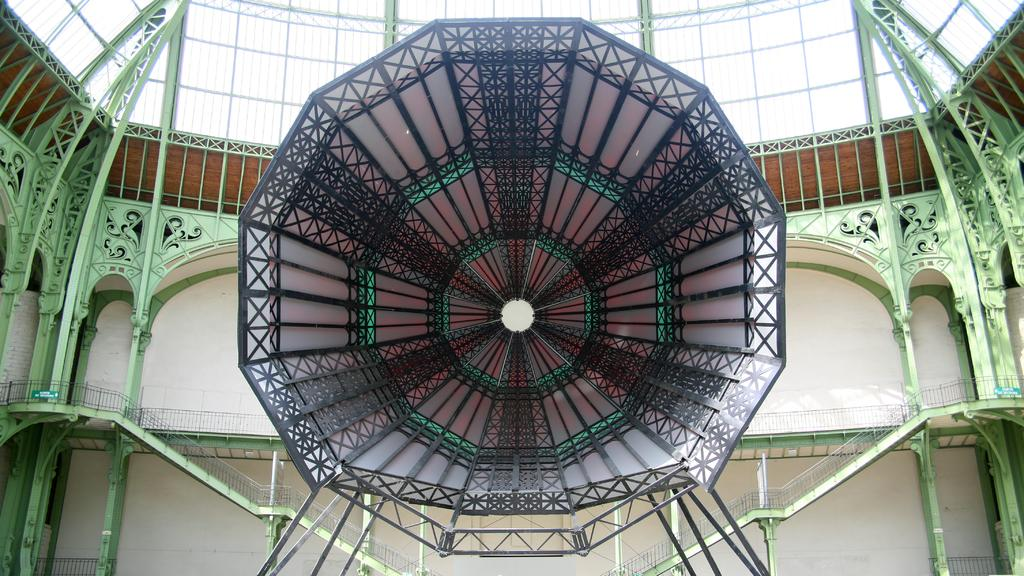What type of location is depicted in the image? The image shows an inside view of a building. What architectural feature can be seen in the image? There are stairs in the image. What safety feature is present in the image? Railings are present in the image. Can you describe the unspecified object or feature in the image? Unfortunately, the provided facts do not specify the nature of the unspecified object or feature in the image. What role does the actor play in the image? There is no actor present in the image, as it depicts an inside view of a building with stairs and railings. 